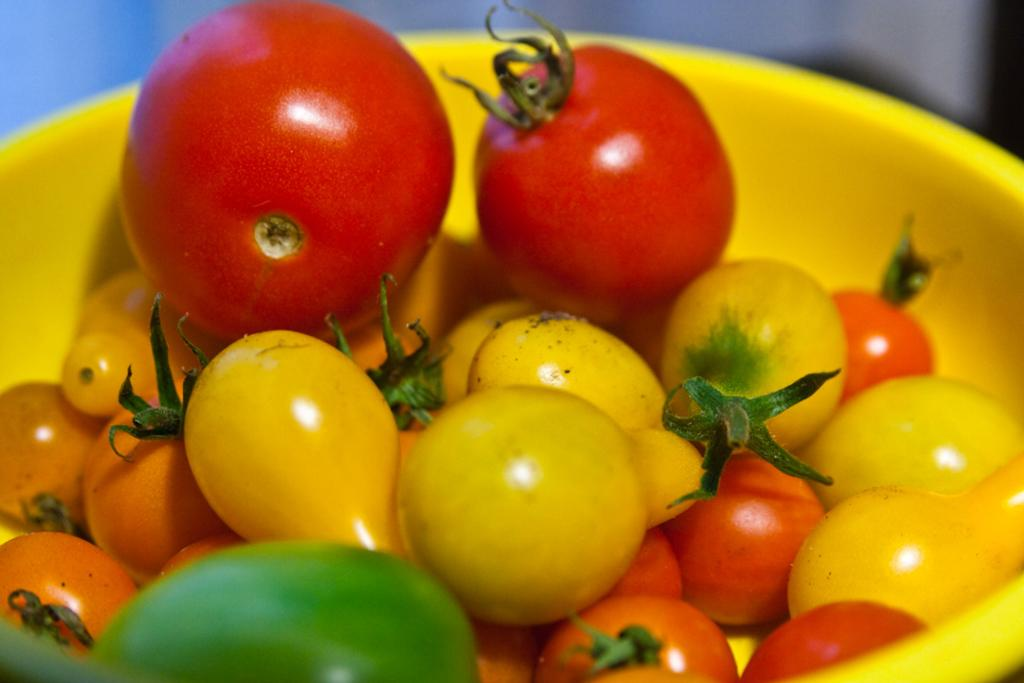What is the main object in the image? There is a bowl in the image. How is the bowl depicted? The bowl appears to be truncated. What is inside the bowl? There are vegetables in the bowl. How are the vegetables depicted? The vegetables are also truncated towards the bottom of the image. Can you describe the background of the image? The background of the image is blurred. How many attempts does it take to fill the bag with vegetables in the image? There is no bag present in the image, and therefore no attempts to fill it with vegetables. 